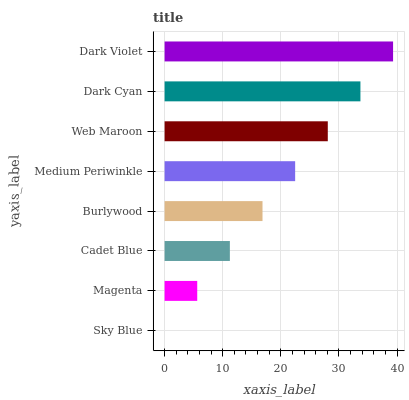Is Sky Blue the minimum?
Answer yes or no. Yes. Is Dark Violet the maximum?
Answer yes or no. Yes. Is Magenta the minimum?
Answer yes or no. No. Is Magenta the maximum?
Answer yes or no. No. Is Magenta greater than Sky Blue?
Answer yes or no. Yes. Is Sky Blue less than Magenta?
Answer yes or no. Yes. Is Sky Blue greater than Magenta?
Answer yes or no. No. Is Magenta less than Sky Blue?
Answer yes or no. No. Is Medium Periwinkle the high median?
Answer yes or no. Yes. Is Burlywood the low median?
Answer yes or no. Yes. Is Burlywood the high median?
Answer yes or no. No. Is Sky Blue the low median?
Answer yes or no. No. 